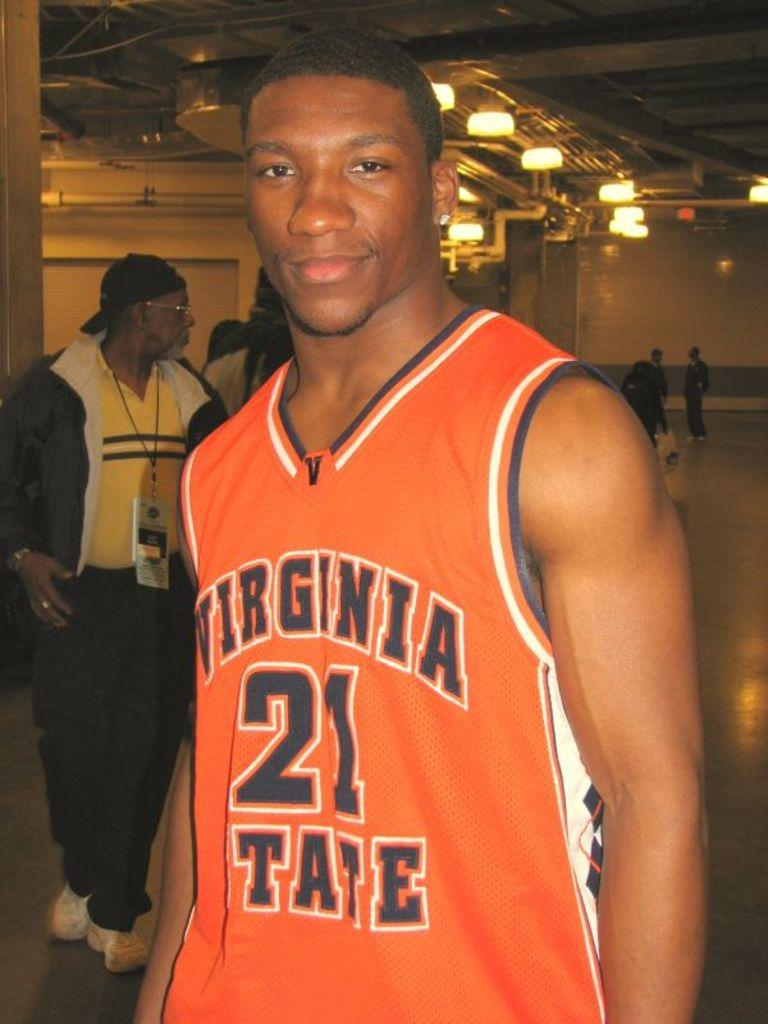<image>
Offer a succinct explanation of the picture presented. the number 21 is on the orange jersey of the man 